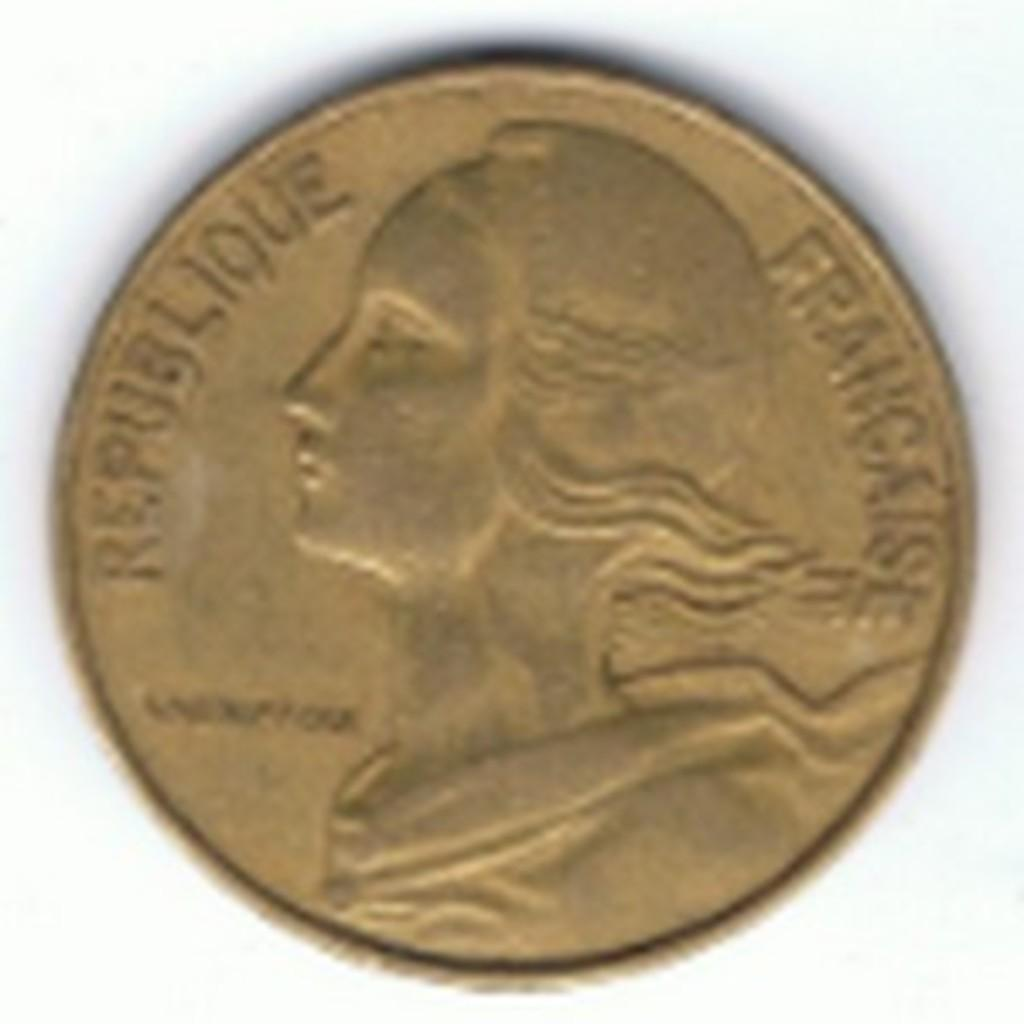<image>
Describe the image concisely. A historical coin originating from France that shows visible signs of wear. 